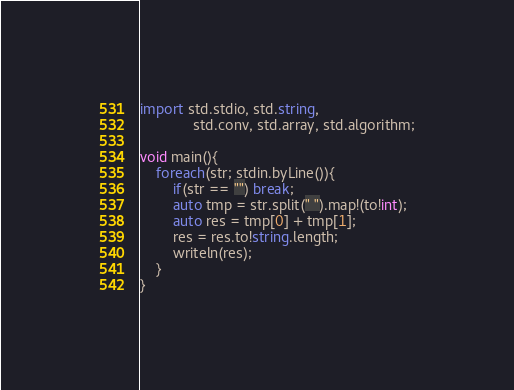<code> <loc_0><loc_0><loc_500><loc_500><_D_>import std.stdio, std.string,
			 std.conv, std.array, std.algorithm;

void main(){
	foreach(str; stdin.byLine()){
		if(str == "") break;
		auto tmp = str.split(" ").map!(to!int);
		auto res = tmp[0] + tmp[1];
		res = res.to!string.length;
		writeln(res);
	}
}</code> 